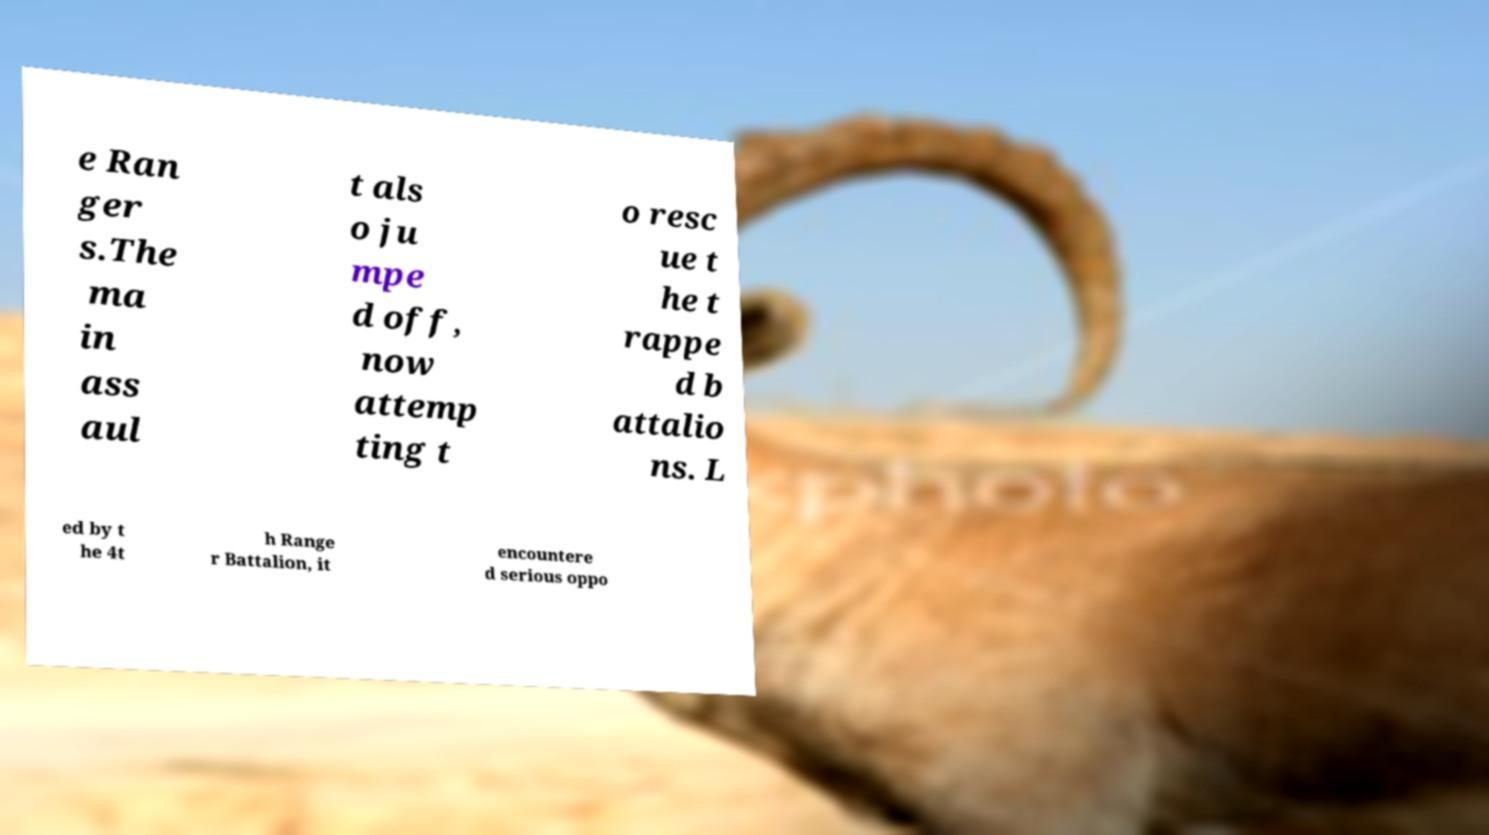Please read and relay the text visible in this image. What does it say? e Ran ger s.The ma in ass aul t als o ju mpe d off, now attemp ting t o resc ue t he t rappe d b attalio ns. L ed by t he 4t h Range r Battalion, it encountere d serious oppo 